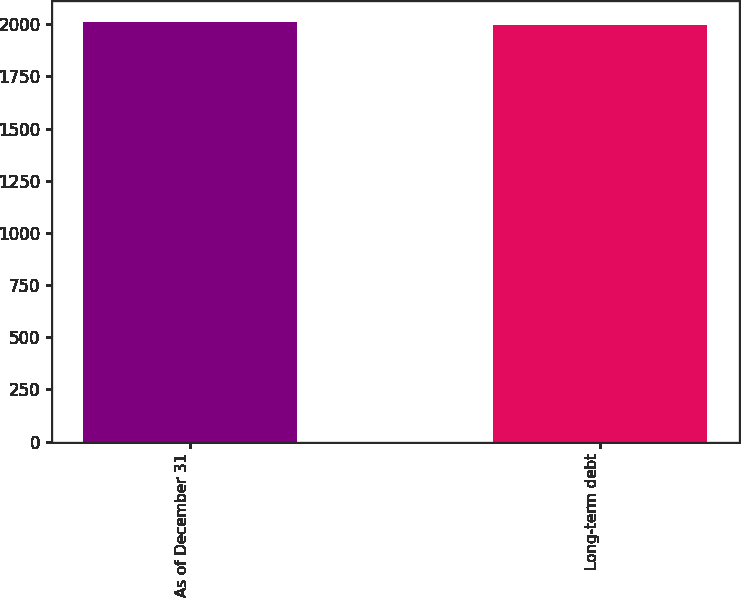Convert chart. <chart><loc_0><loc_0><loc_500><loc_500><bar_chart><fcel>As of December 31<fcel>Long-term debt<nl><fcel>2009<fcel>1998<nl></chart> 